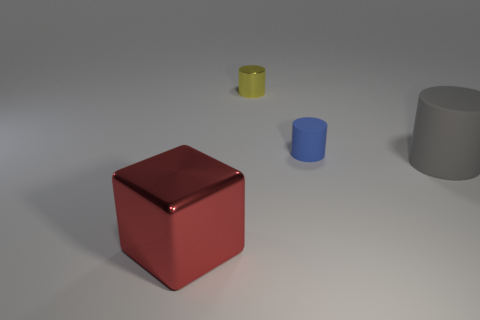Could you speculate on the context or purpose of this arrangement of objects? While this scene could be a simple 3D rendering exercise focusing on geometry, shading, and light, it might also represent an artistic composition emphasizing color contrast and the interplay of forms, or possibly a setup for a physics demonstration on the properties of various shapes and materials. 